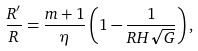Convert formula to latex. <formula><loc_0><loc_0><loc_500><loc_500>\frac { R ^ { \prime } } { R } = \frac { m + 1 } { \eta } \left ( 1 - \frac { 1 } { R H \sqrt { G } } \right ) ,</formula> 